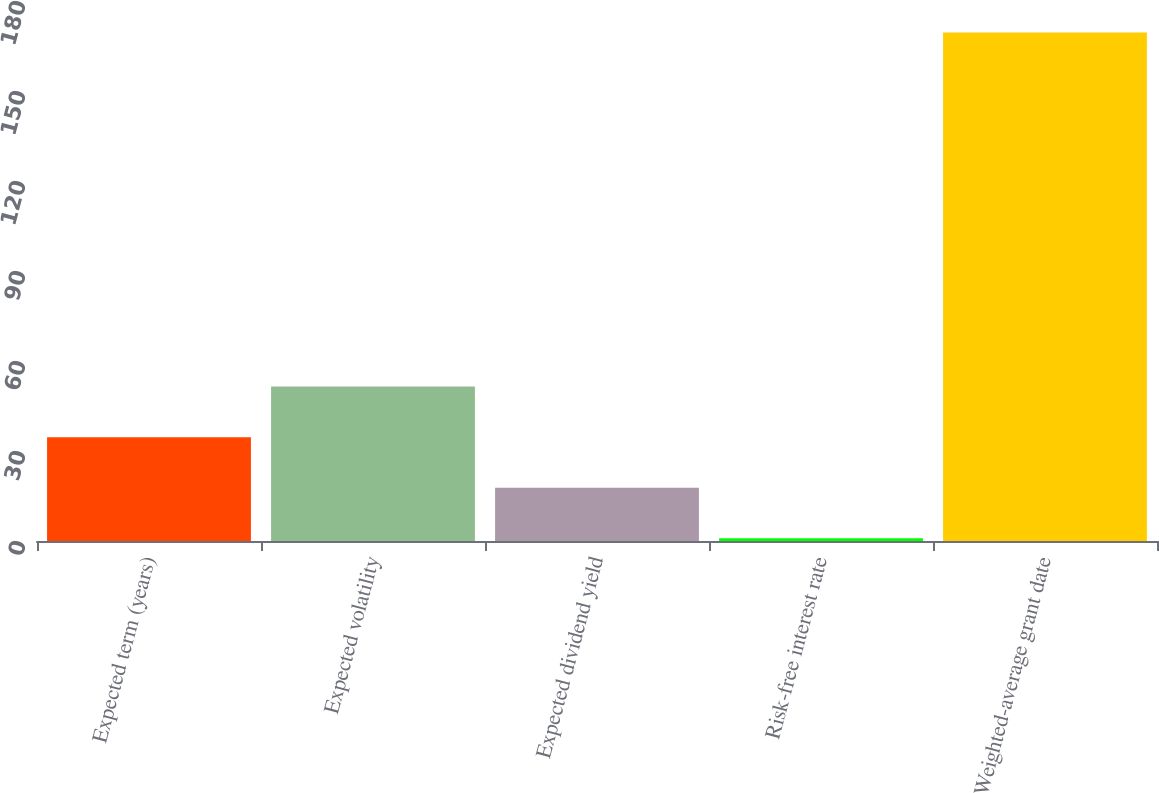<chart> <loc_0><loc_0><loc_500><loc_500><bar_chart><fcel>Expected term (years)<fcel>Expected volatility<fcel>Expected dividend yield<fcel>Risk-free interest rate<fcel>Weighted-average grant date<nl><fcel>34.62<fcel>51.48<fcel>17.76<fcel>0.9<fcel>169.47<nl></chart> 